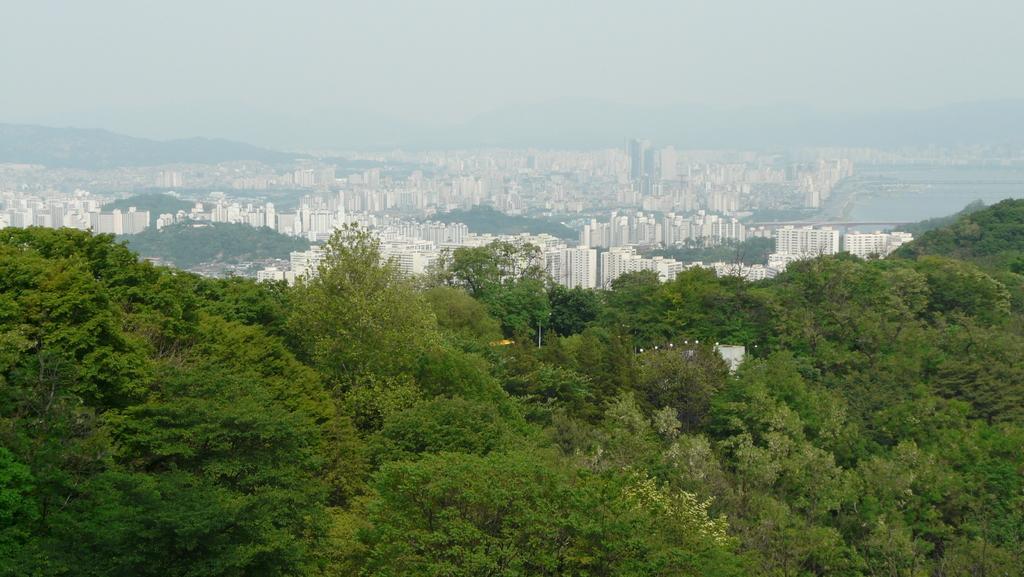Can you describe this image briefly? In this image we can see many trees. In the background there are buildings. Also there is sky. 